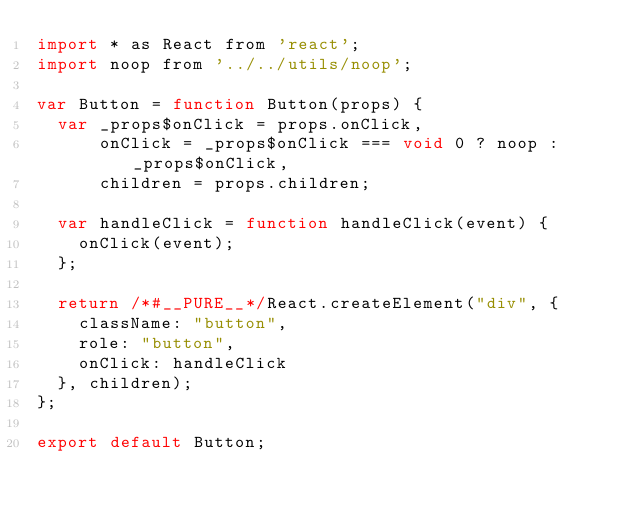Convert code to text. <code><loc_0><loc_0><loc_500><loc_500><_JavaScript_>import * as React from 'react';
import noop from '../../utils/noop';

var Button = function Button(props) {
  var _props$onClick = props.onClick,
      onClick = _props$onClick === void 0 ? noop : _props$onClick,
      children = props.children;

  var handleClick = function handleClick(event) {
    onClick(event);
  };

  return /*#__PURE__*/React.createElement("div", {
    className: "button",
    role: "button",
    onClick: handleClick
  }, children);
};

export default Button;</code> 